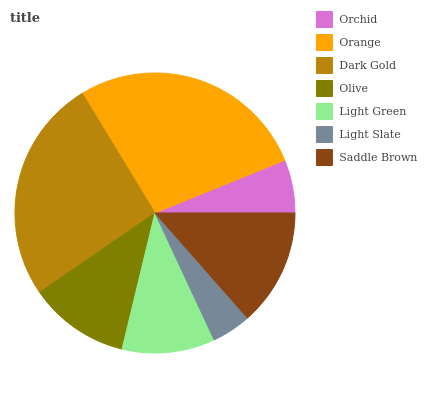Is Light Slate the minimum?
Answer yes or no. Yes. Is Orange the maximum?
Answer yes or no. Yes. Is Dark Gold the minimum?
Answer yes or no. No. Is Dark Gold the maximum?
Answer yes or no. No. Is Orange greater than Dark Gold?
Answer yes or no. Yes. Is Dark Gold less than Orange?
Answer yes or no. Yes. Is Dark Gold greater than Orange?
Answer yes or no. No. Is Orange less than Dark Gold?
Answer yes or no. No. Is Olive the high median?
Answer yes or no. Yes. Is Olive the low median?
Answer yes or no. Yes. Is Orchid the high median?
Answer yes or no. No. Is Orange the low median?
Answer yes or no. No. 